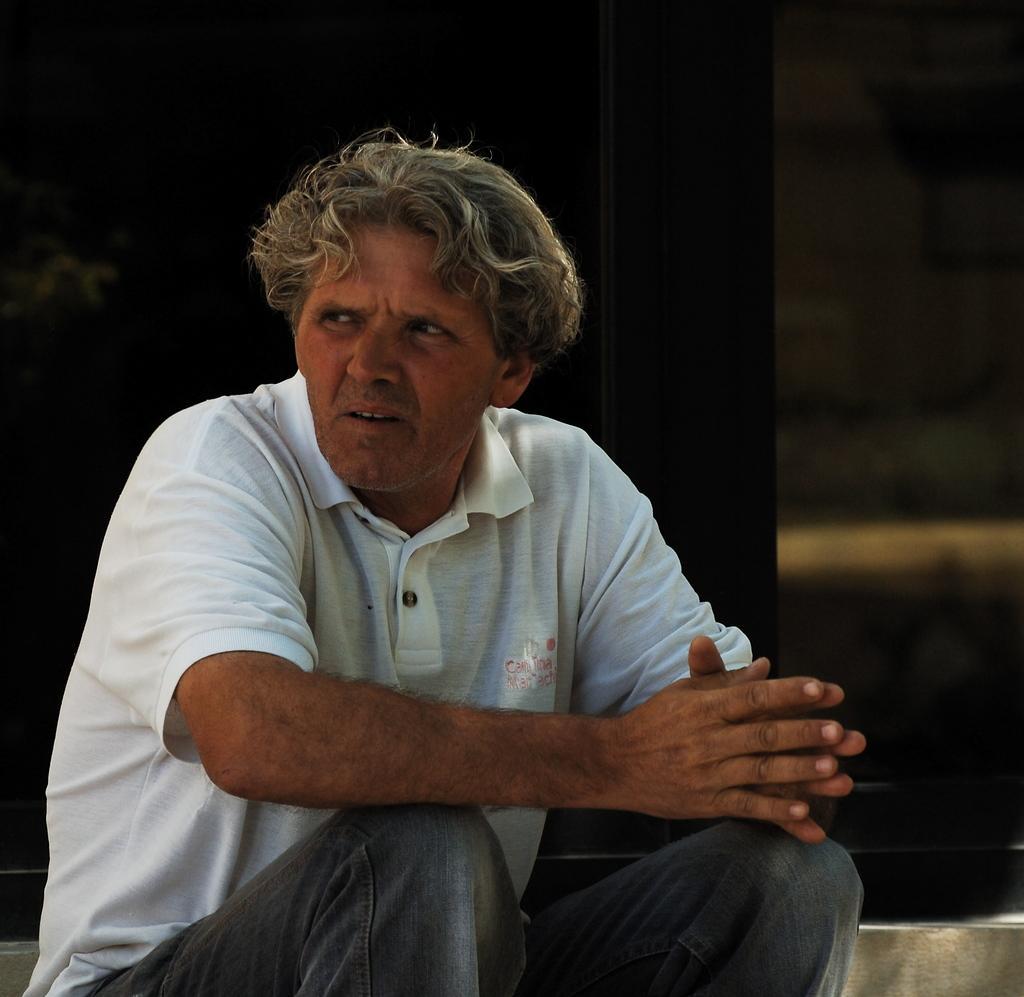How would you summarize this image in a sentence or two? In this image there is a man sitting, he is wearing a T-shirt, there is an object behind the man, the background of the image is dark. 